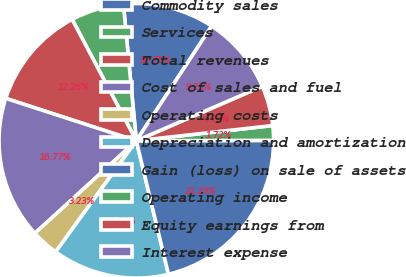<chart> <loc_0><loc_0><loc_500><loc_500><pie_chart><fcel>Commodity sales<fcel>Services<fcel>Total revenues<fcel>Cost of sales and fuel<fcel>Operating costs<fcel>Depreciation and amortization<fcel>Gain (loss) on sale of assets<fcel>Operating income<fcel>Equity earnings from<fcel>Interest expense<nl><fcel>10.75%<fcel>6.24%<fcel>12.26%<fcel>16.77%<fcel>3.23%<fcel>13.76%<fcel>21.29%<fcel>1.72%<fcel>4.73%<fcel>9.25%<nl></chart> 